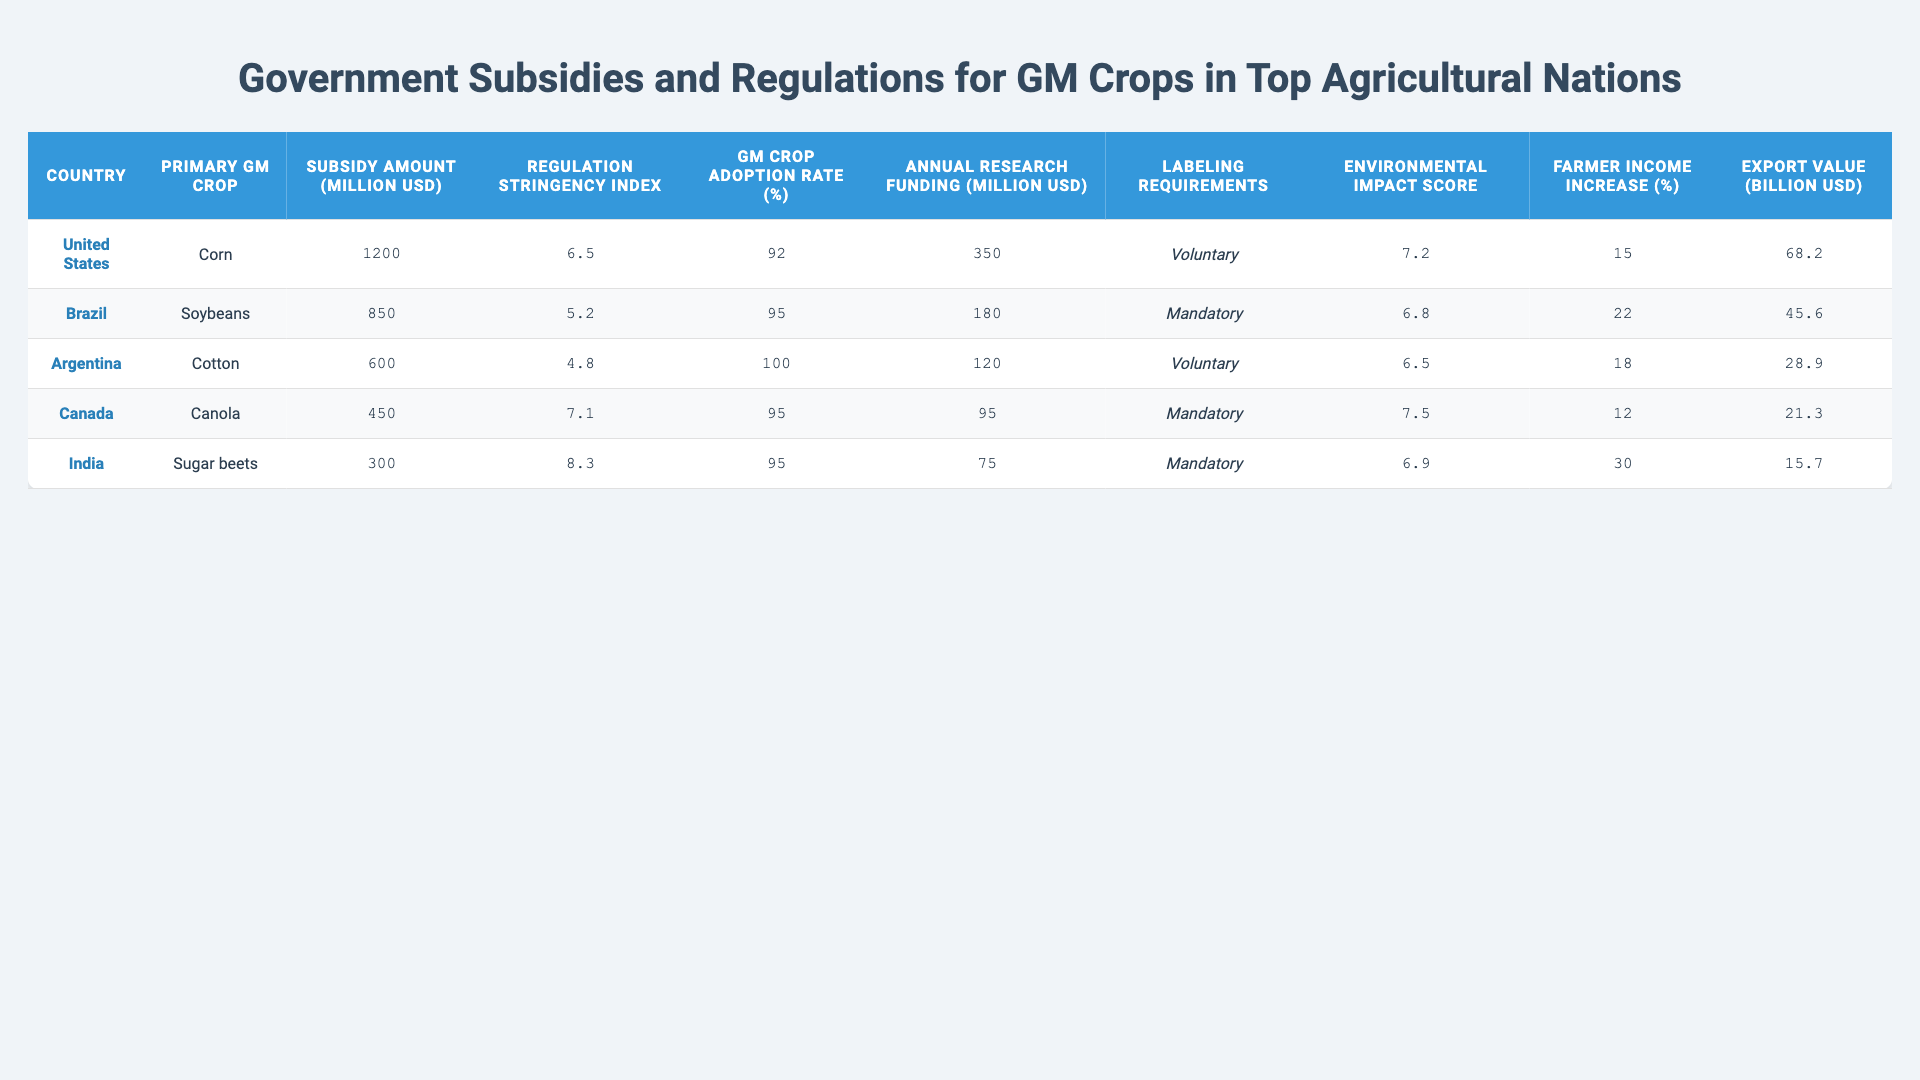What is the subsidy amount for GM crops in the United States? The table lists the subsidy amount for the United States as 1200 million USD under the "Subsidy Amount (Million USD)" column.
Answer: 1200 million USD Which country has the highest regulation stringency index? By looking at the "Regulation Stringency Index" column, India has the highest value of 8.3, compared to the others.
Answer: India What is the average GM crop adoption rate among the listed countries? To find the average, sum the adoption rates: (92 + 95 + 100 + 95 + 95) = 477. Divide by the number of countries, which is 5: 477/5 = 95.4.
Answer: 95.4% True or False: Brazil's labeling requirements for GM crops are voluntary. Looking at the "Labeling Requirements" column, Brazil has "Mandatory" labeling requirements, making the statement false.
Answer: False Which country saw the greatest increase in farmer income due to GM crop adoption, and what was the percentage? By comparing the "Farmer Income Increase (%)" values, India shows the highest increase at 30%, making it the leader in this area.
Answer: India, 30% What is the total export value of GM crops for the countries listed in the table? The total export value is calculated by summing the values: (68.2 + 45.6 + 28.9 + 21.3 + 15.7) = 179.7 billion USD.
Answer: 179.7 billion USD Which country has the lowest annual research funding for GM crops? By evaluating the "Annual Research Funding (Million USD)" column, we see India has the lowest funding at 75 million USD.
Answer: India, 75 million USD What is the difference in subsidy amounts between the United States and Canada? The subsidy amount for the United States is 1200 million USD and for Canada, it is 450 million USD. The difference is 1200 - 450 = 750 million USD.
Answer: 750 million USD Which country has a higher environmental impact assessment score: Argentina or India? The scores in the "Environmental Impact Score" column show Argentina at 6.5 and India at 6.9. Since 6.9 > 6.5, India has a higher score.
Answer: India Calculate the average farmer income increase percentage for Brazil, Argentina, and Canada. The sum of their percentages is (22 + 18 + 12) = 52. There are three countries, so the average is 52/3 = 17.33.
Answer: 17.33% Which country has the highest GM crop adoption rate and what crop is it primarily growing? The table shows Argentina with a 100% GM crop adoption rate, and it primarily cultivates Soybeans.
Answer: Argentina, Soybeans 